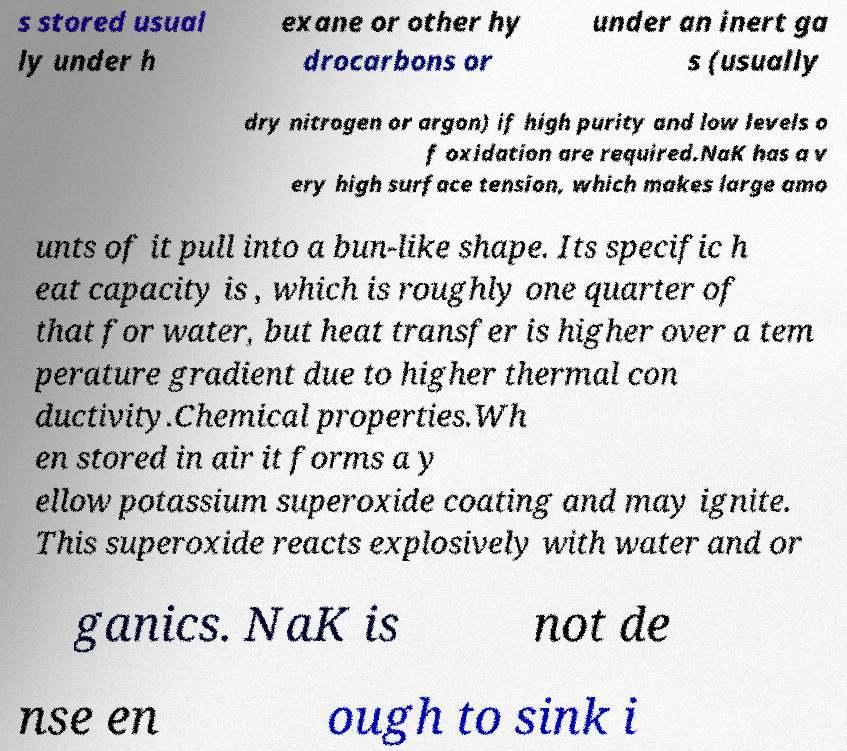What messages or text are displayed in this image? I need them in a readable, typed format. s stored usual ly under h exane or other hy drocarbons or under an inert ga s (usually dry nitrogen or argon) if high purity and low levels o f oxidation are required.NaK has a v ery high surface tension, which makes large amo unts of it pull into a bun-like shape. Its specific h eat capacity is , which is roughly one quarter of that for water, but heat transfer is higher over a tem perature gradient due to higher thermal con ductivity.Chemical properties.Wh en stored in air it forms a y ellow potassium superoxide coating and may ignite. This superoxide reacts explosively with water and or ganics. NaK is not de nse en ough to sink i 